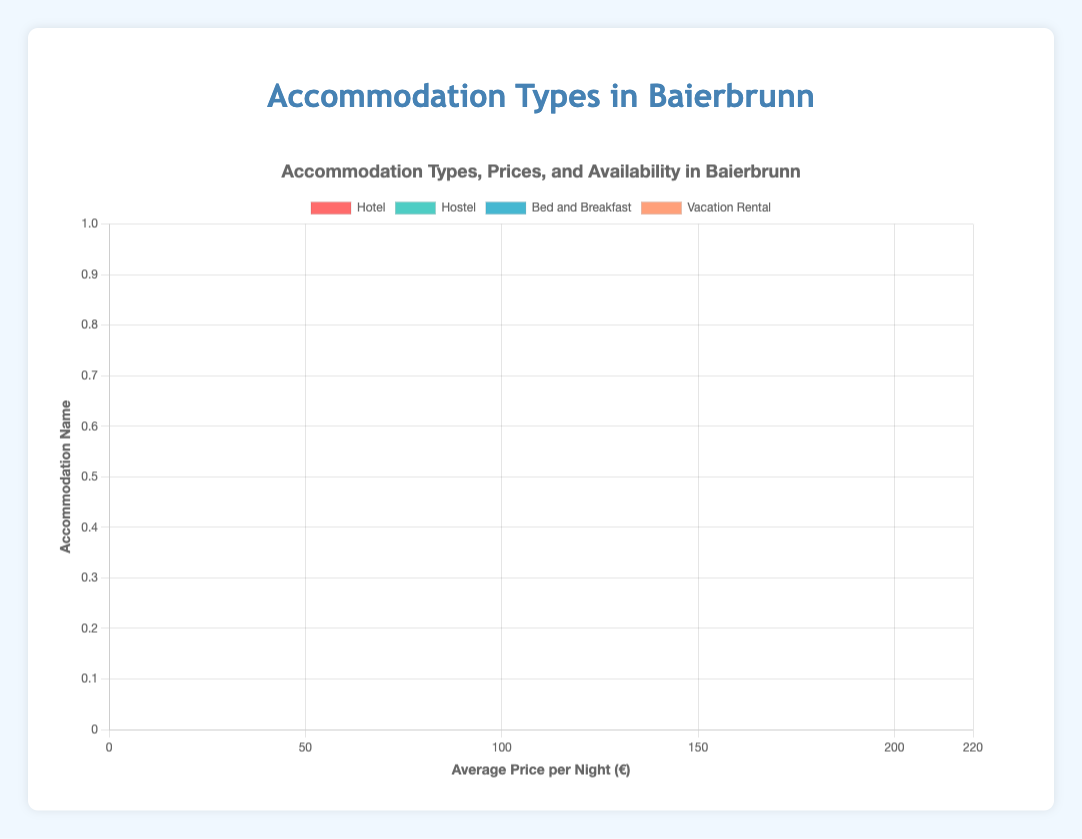How many more units does the Youth Hostel Baierbrunn have compared to the Country Charm B&B? Youth Hostel Baierbrunn has 45 units and Country Charm B&B has 15 units. Difference = 45 - 15 = 30 units.
Answer: 30 units Which accommodation type has the highest average price per night, and what is that price? The highest average price per night is found in the Vacation Rental category. The highest price is for Mountain View Homes at €200 per night.
Answer: Vacation Rental, €200 Between the Baierbrunn Grand Hotel and Forest View Hotel, which one offers a higher number of units, and how many more units does it offer? Baierbrunn Grand Hotel has 50 units while Forest View Hotel has 20 units. Difference = 50 - 20 = 30 units.
Answer: Baierbrunn Grand Hotel, 30 units What's the total number of units available across all hostels? Baierbrunn Backpackers Hostel: 60 units, Youth Hostel Baierbrunn: 45 units, Riverbank Hostel: 35 units. Total = 60 + 45 + 35 = 140 units.
Answer: 140 units Compare the average prices of Cozy Corner B&B and Rustic Retreat B&B. Which one is more expensive, and by how much? Cozy Corner B&B costs €80 per night while Rustic Retreat B&B costs €75 per night. Difference = 80 - 75 = 5 euros.
Answer: Cozy Corner B&B, €5 What are the two vacation rentals with the lowest prices, and what are their average prices per night? The two vacation rentals with the lowest prices are Baierbrunn Cozy Apartments (€150 per night) and Lakeside Villas (€180 per night).
Answer: Baierbrunn Cozy Apartments: €150, Lakeside Villas: €180 Which accommodation type has the most units available in a single location, and what is the name of that location? Hostel category with Baierbrunn Backpackers Hostel having the highest number of units available at 60 units.
Answer: Hostel, Baierbrunn Backpackers Hostel How does the total number of units for hotels compare to the total number of units for bed and breakfasts? Hotels: Baierbrunn Grand Hotel (50), Edelweiss Inn (30), Forest View Hotel (20) = 100 units. Bed and Breakfast: Cozy Corner B&B (10), Country Charm B&B (15), Rustic Retreat B&B (8) = 33 units.
Answer: Hotels: 100 units, Bed and Breakfast: 33 units Which hostel has the lowest average price per night, and what is that price? Baierbrunn Backpackers Hostel has the lowest average price per night in the hostel category at €35 per night.
Answer: Baierbrunn Backpackers Hostel, €35 